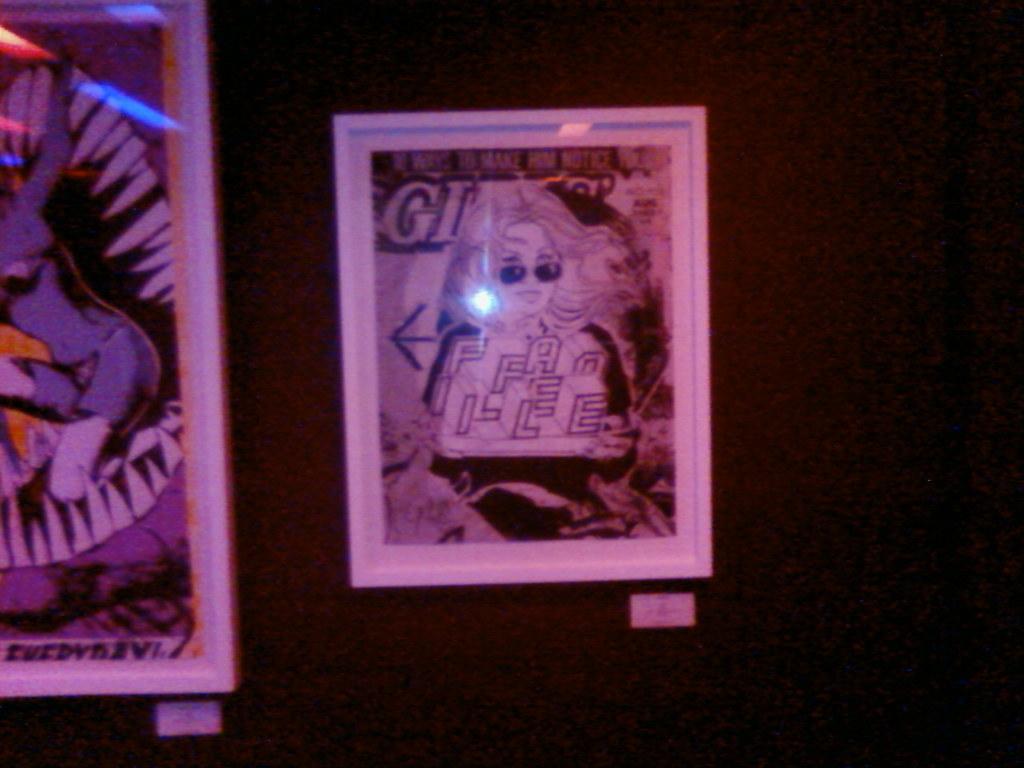What letter comes after the g?
Give a very brief answer. I. 